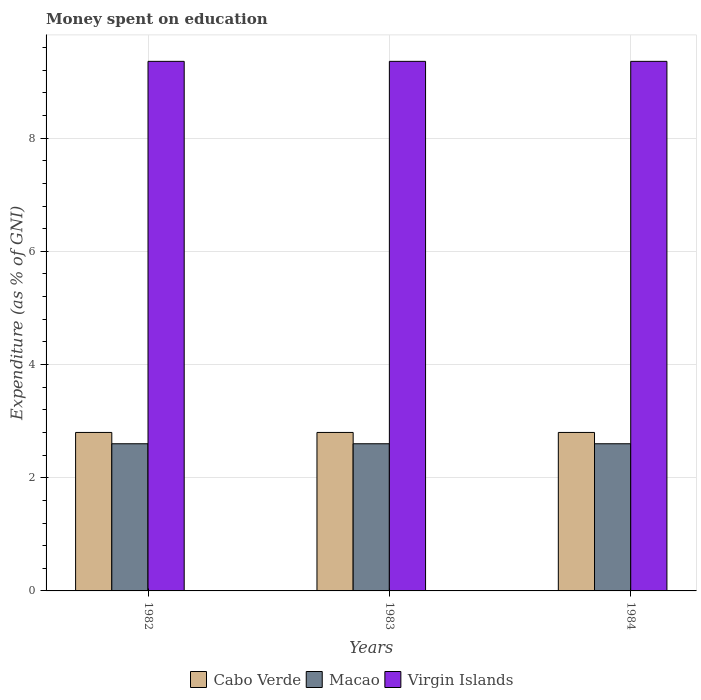Are the number of bars on each tick of the X-axis equal?
Your answer should be compact. Yes. What is the label of the 2nd group of bars from the left?
Your answer should be compact. 1983. In how many cases, is the number of bars for a given year not equal to the number of legend labels?
Make the answer very short. 0. What is the amount of money spent on education in Cabo Verde in 1982?
Provide a succinct answer. 2.8. Across all years, what is the maximum amount of money spent on education in Virgin Islands?
Make the answer very short. 9.36. In which year was the amount of money spent on education in Macao maximum?
Offer a terse response. 1982. What is the total amount of money spent on education in Virgin Islands in the graph?
Your answer should be compact. 28.07. What is the difference between the amount of money spent on education in Virgin Islands in 1982 and that in 1983?
Ensure brevity in your answer.  0. What is the difference between the amount of money spent on education in Virgin Islands in 1982 and the amount of money spent on education in Macao in 1983?
Your answer should be compact. 6.76. What is the average amount of money spent on education in Macao per year?
Provide a succinct answer. 2.6. In the year 1983, what is the difference between the amount of money spent on education in Cabo Verde and amount of money spent on education in Macao?
Provide a short and direct response. 0.2. In how many years, is the amount of money spent on education in Virgin Islands greater than 1.2000000000000002 %?
Offer a very short reply. 3. What is the ratio of the amount of money spent on education in Macao in 1982 to that in 1984?
Give a very brief answer. 1. Is the difference between the amount of money spent on education in Cabo Verde in 1983 and 1984 greater than the difference between the amount of money spent on education in Macao in 1983 and 1984?
Ensure brevity in your answer.  No. What is the difference between the highest and the second highest amount of money spent on education in Cabo Verde?
Provide a short and direct response. 0. What is the difference between the highest and the lowest amount of money spent on education in Virgin Islands?
Provide a short and direct response. 0. In how many years, is the amount of money spent on education in Macao greater than the average amount of money spent on education in Macao taken over all years?
Your response must be concise. 0. What does the 2nd bar from the left in 1984 represents?
Your answer should be compact. Macao. What does the 2nd bar from the right in 1984 represents?
Offer a very short reply. Macao. Is it the case that in every year, the sum of the amount of money spent on education in Cabo Verde and amount of money spent on education in Macao is greater than the amount of money spent on education in Virgin Islands?
Provide a short and direct response. No. Are all the bars in the graph horizontal?
Provide a succinct answer. No. Does the graph contain grids?
Your answer should be compact. Yes. How are the legend labels stacked?
Make the answer very short. Horizontal. What is the title of the graph?
Provide a short and direct response. Money spent on education. What is the label or title of the Y-axis?
Ensure brevity in your answer.  Expenditure (as % of GNI). What is the Expenditure (as % of GNI) in Macao in 1982?
Give a very brief answer. 2.6. What is the Expenditure (as % of GNI) in Virgin Islands in 1982?
Provide a succinct answer. 9.36. What is the Expenditure (as % of GNI) in Cabo Verde in 1983?
Offer a terse response. 2.8. What is the Expenditure (as % of GNI) of Virgin Islands in 1983?
Give a very brief answer. 9.36. What is the Expenditure (as % of GNI) in Cabo Verde in 1984?
Offer a very short reply. 2.8. What is the Expenditure (as % of GNI) in Macao in 1984?
Keep it short and to the point. 2.6. What is the Expenditure (as % of GNI) in Virgin Islands in 1984?
Your answer should be very brief. 9.36. Across all years, what is the maximum Expenditure (as % of GNI) of Cabo Verde?
Provide a short and direct response. 2.8. Across all years, what is the maximum Expenditure (as % of GNI) of Macao?
Make the answer very short. 2.6. Across all years, what is the maximum Expenditure (as % of GNI) in Virgin Islands?
Provide a short and direct response. 9.36. Across all years, what is the minimum Expenditure (as % of GNI) of Cabo Verde?
Provide a succinct answer. 2.8. Across all years, what is the minimum Expenditure (as % of GNI) in Macao?
Provide a short and direct response. 2.6. Across all years, what is the minimum Expenditure (as % of GNI) of Virgin Islands?
Your response must be concise. 9.36. What is the total Expenditure (as % of GNI) in Macao in the graph?
Provide a short and direct response. 7.8. What is the total Expenditure (as % of GNI) of Virgin Islands in the graph?
Provide a succinct answer. 28.07. What is the difference between the Expenditure (as % of GNI) of Macao in 1982 and that in 1983?
Provide a succinct answer. 0. What is the difference between the Expenditure (as % of GNI) in Macao in 1982 and that in 1984?
Your answer should be compact. 0. What is the difference between the Expenditure (as % of GNI) of Virgin Islands in 1983 and that in 1984?
Provide a short and direct response. 0. What is the difference between the Expenditure (as % of GNI) in Cabo Verde in 1982 and the Expenditure (as % of GNI) in Virgin Islands in 1983?
Provide a short and direct response. -6.56. What is the difference between the Expenditure (as % of GNI) in Macao in 1982 and the Expenditure (as % of GNI) in Virgin Islands in 1983?
Provide a succinct answer. -6.76. What is the difference between the Expenditure (as % of GNI) of Cabo Verde in 1982 and the Expenditure (as % of GNI) of Macao in 1984?
Offer a very short reply. 0.2. What is the difference between the Expenditure (as % of GNI) of Cabo Verde in 1982 and the Expenditure (as % of GNI) of Virgin Islands in 1984?
Offer a very short reply. -6.56. What is the difference between the Expenditure (as % of GNI) in Macao in 1982 and the Expenditure (as % of GNI) in Virgin Islands in 1984?
Your response must be concise. -6.76. What is the difference between the Expenditure (as % of GNI) of Cabo Verde in 1983 and the Expenditure (as % of GNI) of Virgin Islands in 1984?
Provide a short and direct response. -6.56. What is the difference between the Expenditure (as % of GNI) in Macao in 1983 and the Expenditure (as % of GNI) in Virgin Islands in 1984?
Keep it short and to the point. -6.76. What is the average Expenditure (as % of GNI) of Cabo Verde per year?
Provide a short and direct response. 2.8. What is the average Expenditure (as % of GNI) in Virgin Islands per year?
Make the answer very short. 9.36. In the year 1982, what is the difference between the Expenditure (as % of GNI) of Cabo Verde and Expenditure (as % of GNI) of Virgin Islands?
Provide a succinct answer. -6.56. In the year 1982, what is the difference between the Expenditure (as % of GNI) of Macao and Expenditure (as % of GNI) of Virgin Islands?
Your answer should be very brief. -6.76. In the year 1983, what is the difference between the Expenditure (as % of GNI) of Cabo Verde and Expenditure (as % of GNI) of Macao?
Provide a short and direct response. 0.2. In the year 1983, what is the difference between the Expenditure (as % of GNI) of Cabo Verde and Expenditure (as % of GNI) of Virgin Islands?
Make the answer very short. -6.56. In the year 1983, what is the difference between the Expenditure (as % of GNI) of Macao and Expenditure (as % of GNI) of Virgin Islands?
Your response must be concise. -6.76. In the year 1984, what is the difference between the Expenditure (as % of GNI) of Cabo Verde and Expenditure (as % of GNI) of Virgin Islands?
Give a very brief answer. -6.56. In the year 1984, what is the difference between the Expenditure (as % of GNI) in Macao and Expenditure (as % of GNI) in Virgin Islands?
Offer a terse response. -6.76. What is the ratio of the Expenditure (as % of GNI) of Macao in 1982 to that in 1983?
Keep it short and to the point. 1. What is the ratio of the Expenditure (as % of GNI) of Virgin Islands in 1982 to that in 1983?
Offer a very short reply. 1. What is the ratio of the Expenditure (as % of GNI) of Virgin Islands in 1983 to that in 1984?
Give a very brief answer. 1. What is the difference between the highest and the second highest Expenditure (as % of GNI) in Macao?
Provide a short and direct response. 0. What is the difference between the highest and the second highest Expenditure (as % of GNI) in Virgin Islands?
Your answer should be compact. 0. What is the difference between the highest and the lowest Expenditure (as % of GNI) in Macao?
Your answer should be compact. 0. What is the difference between the highest and the lowest Expenditure (as % of GNI) in Virgin Islands?
Make the answer very short. 0. 